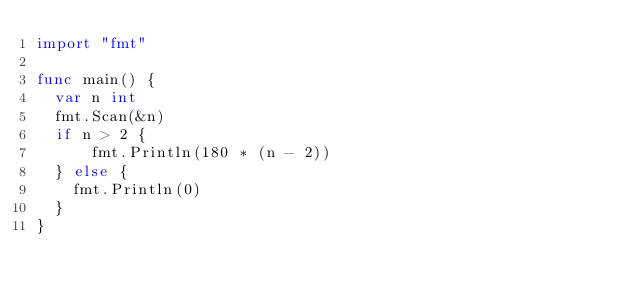<code> <loc_0><loc_0><loc_500><loc_500><_Go_>import "fmt"

func main() {
  var n int
  fmt.Scan(&n)
  if n > 2 {
	  fmt.Println(180 * (n - 2))
  } else {
    fmt.Println(0)
  }
}</code> 